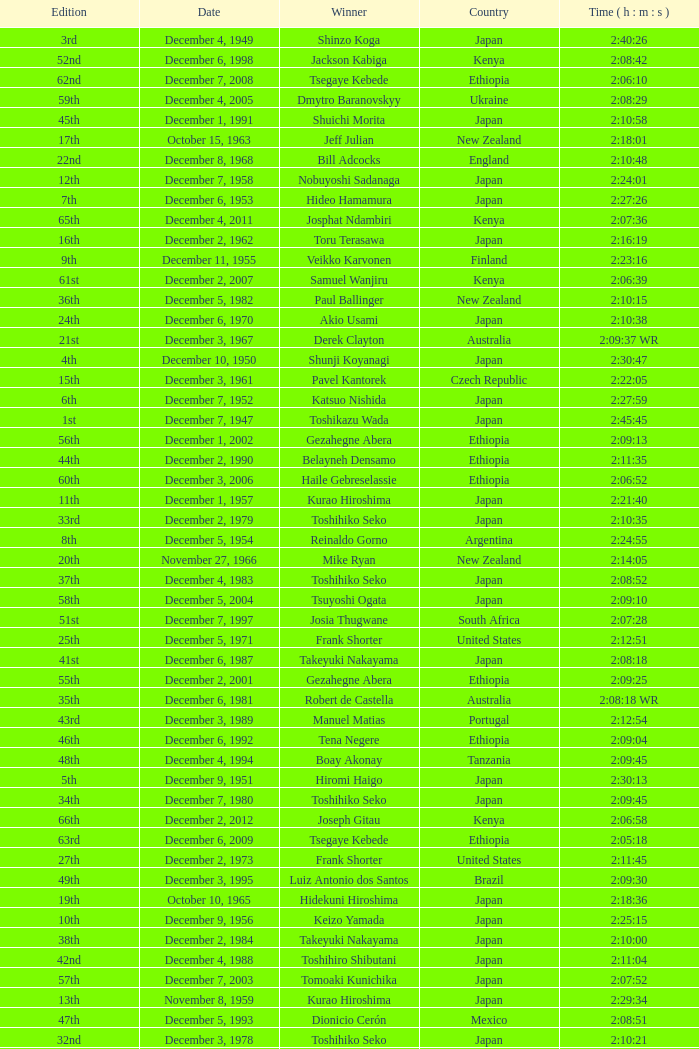What was the nationality of the winner of the 42nd Edition? Japan. 